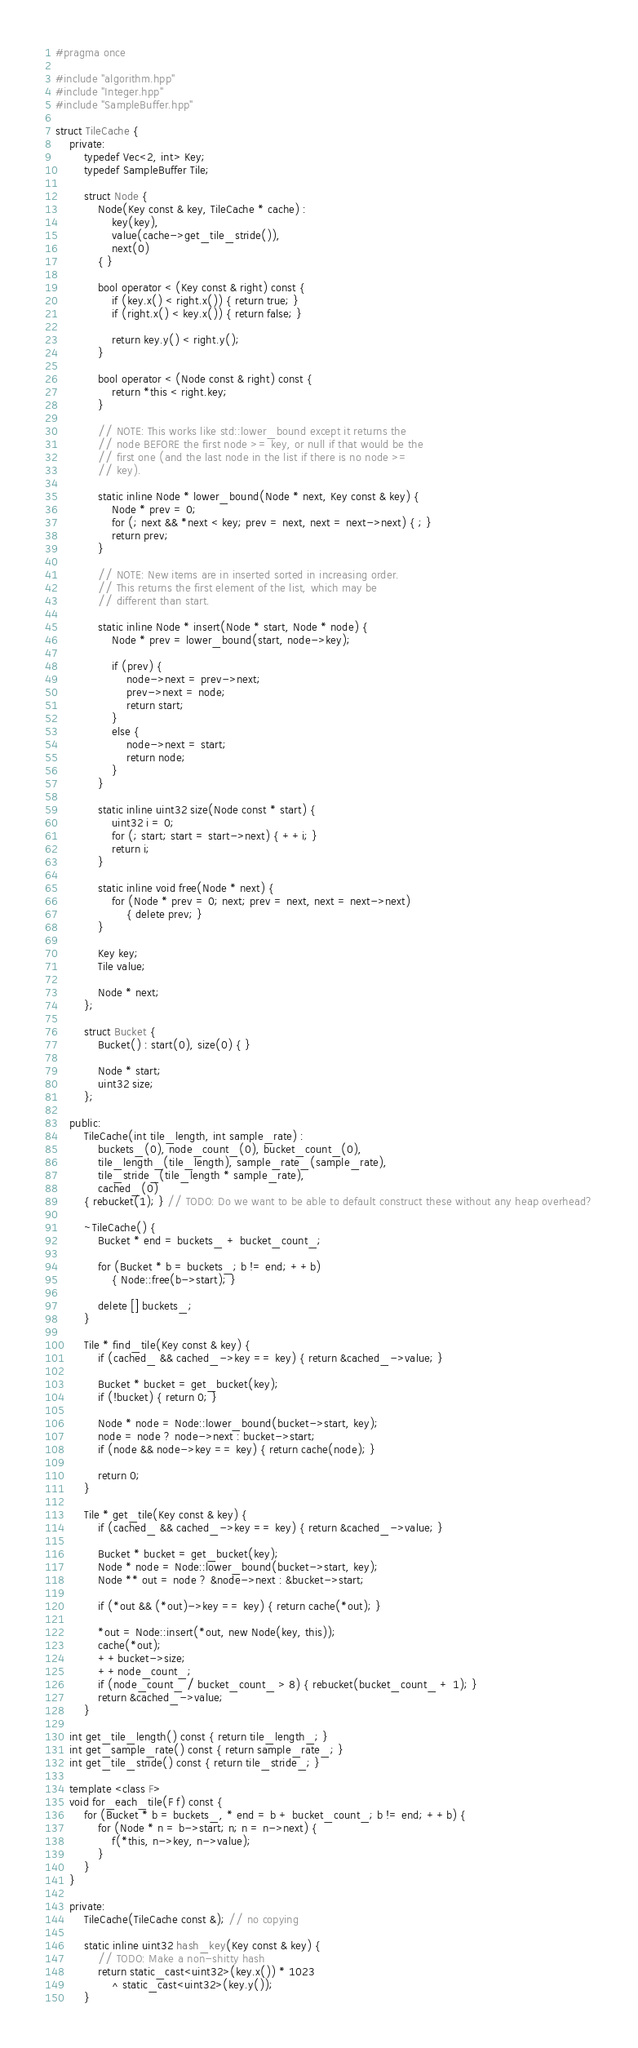Convert code to text. <code><loc_0><loc_0><loc_500><loc_500><_C++_>#pragma once

#include "algorithm.hpp"
#include "Integer.hpp"
#include "SampleBuffer.hpp"

struct TileCache {
	private:
		typedef Vec<2, int> Key;
		typedef SampleBuffer Tile;

		struct Node {
			Node(Key const & key, TileCache * cache) :
				key(key),
				value(cache->get_tile_stride()),
				next(0)
			{ }

			bool operator < (Key const & right) const {
				if (key.x() < right.x()) { return true; }
				if (right.x() < key.x()) { return false; }

				return key.y() < right.y();
			}

			bool operator < (Node const & right) const {
				return *this < right.key;
			}

			// NOTE: This works like std::lower_bound except it returns the
			// node BEFORE the first node >= key, or null if that would be the
			// first one (and the last node in the list if there is no node >=
			// key).

			static inline Node * lower_bound(Node * next, Key const & key) {
				Node * prev = 0;
				for (; next && *next < key; prev = next, next = next->next) { ; }
				return prev;
			}

			// NOTE: New items are in inserted sorted in increasing order.
			// This returns the first element of the list, which may be
			// different than start.

			static inline Node * insert(Node * start, Node * node) {
				Node * prev = lower_bound(start, node->key);

				if (prev) {
					node->next = prev->next;
					prev->next = node;
					return start;
				}
				else {
					node->next = start;
					return node;
				}
			}

			static inline uint32 size(Node const * start) {
				uint32 i = 0;
				for (; start; start = start->next) { ++i; }
				return i;
			}

			static inline void free(Node * next) {
				for (Node * prev = 0; next; prev = next, next = next->next)
					{ delete prev; }
			}

			Key key;
			Tile value;

			Node * next;
		};

		struct Bucket {
			Bucket() : start(0), size(0) { }

			Node * start; 
			uint32 size;
		};

	public:
		TileCache(int tile_length, int sample_rate) :
			buckets_(0), node_count_(0), bucket_count_(0),
			tile_length_(tile_length), sample_rate_(sample_rate),
			tile_stride_(tile_length * sample_rate),
			cached_(0)
		{ rebucket(1); } // TODO: Do we want to be able to default construct these without any heap overhead?

		~TileCache() {
			Bucket * end = buckets_ + bucket_count_;

			for (Bucket * b = buckets_; b != end; ++b)
				{ Node::free(b->start); }

			delete [] buckets_;
		}

		Tile * find_tile(Key const & key) {
			if (cached_ && cached_->key == key) { return &cached_->value; }

			Bucket * bucket = get_bucket(key);
			if (!bucket) { return 0; }

			Node * node = Node::lower_bound(bucket->start, key);
			node = node ? node->next : bucket->start;
			if (node && node->key == key) { return cache(node); }

			return 0;
		}

		Tile * get_tile(Key const & key) {
			if (cached_ && cached_->key == key) { return &cached_->value; }

			Bucket * bucket = get_bucket(key);
			Node * node = Node::lower_bound(bucket->start, key);
			Node ** out = node ? &node->next : &bucket->start;

			if (*out && (*out)->key == key) { return cache(*out); }

			*out = Node::insert(*out, new Node(key, this));
			cache(*out);
			++bucket->size;
			++node_count_;
			if (node_count_ / bucket_count_ > 8) { rebucket(bucket_count_ + 1); }
			return &cached_->value;
		}

	int get_tile_length() const { return tile_length_; }
	int get_sample_rate() const { return sample_rate_; }
	int get_tile_stride() const { return tile_stride_; }

	template <class F>
	void for_each_tile(F f) const {
		for (Bucket * b = buckets_, * end = b + bucket_count_; b != end; ++b) {
			for (Node * n = b->start; n; n = n->next) {
				f(*this, n->key, n->value);
			}
		}
	}

	private:
		TileCache(TileCache const &); // no copying

		static inline uint32 hash_key(Key const & key) {
			// TODO: Make a non-shitty hash
			return static_cast<uint32>(key.x()) * 1023
				^ static_cast<uint32>(key.y());
		}
</code> 